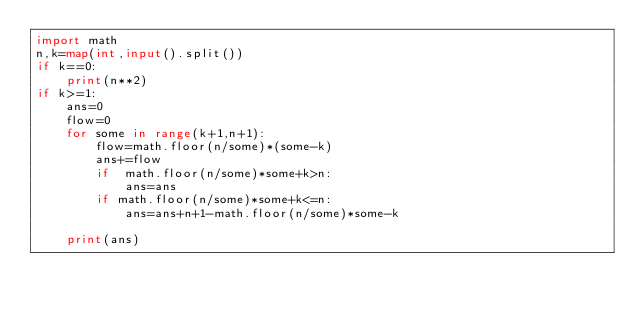Convert code to text. <code><loc_0><loc_0><loc_500><loc_500><_Python_>import math 
n,k=map(int,input().split())
if k==0:
    print(n**2)
if k>=1:
    ans=0
    flow=0
    for some in range(k+1,n+1):
        flow=math.floor(n/some)*(some-k)
        ans+=flow
        if  math.floor(n/some)*some+k>n:
            ans=ans
        if math.floor(n/some)*some+k<=n:
            ans=ans+n+1-math.floor(n/some)*some-k

    print(ans)</code> 